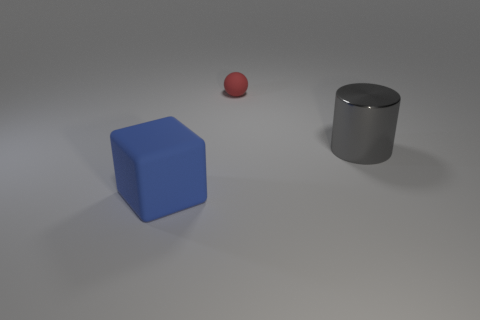The object that is both to the left of the large gray cylinder and to the right of the big blue thing is what color? red 